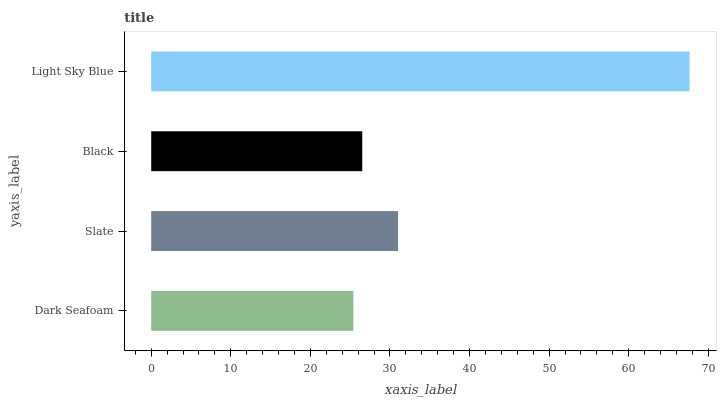Is Dark Seafoam the minimum?
Answer yes or no. Yes. Is Light Sky Blue the maximum?
Answer yes or no. Yes. Is Slate the minimum?
Answer yes or no. No. Is Slate the maximum?
Answer yes or no. No. Is Slate greater than Dark Seafoam?
Answer yes or no. Yes. Is Dark Seafoam less than Slate?
Answer yes or no. Yes. Is Dark Seafoam greater than Slate?
Answer yes or no. No. Is Slate less than Dark Seafoam?
Answer yes or no. No. Is Slate the high median?
Answer yes or no. Yes. Is Black the low median?
Answer yes or no. Yes. Is Dark Seafoam the high median?
Answer yes or no. No. Is Light Sky Blue the low median?
Answer yes or no. No. 